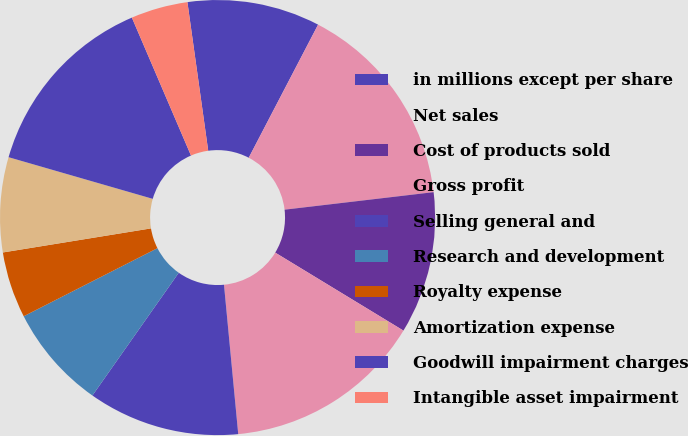Convert chart. <chart><loc_0><loc_0><loc_500><loc_500><pie_chart><fcel>in millions except per share<fcel>Net sales<fcel>Cost of products sold<fcel>Gross profit<fcel>Selling general and<fcel>Research and development<fcel>Royalty expense<fcel>Amortization expense<fcel>Goodwill impairment charges<fcel>Intangible asset impairment<nl><fcel>9.86%<fcel>15.49%<fcel>10.56%<fcel>14.79%<fcel>11.27%<fcel>7.75%<fcel>4.93%<fcel>7.04%<fcel>14.08%<fcel>4.23%<nl></chart> 